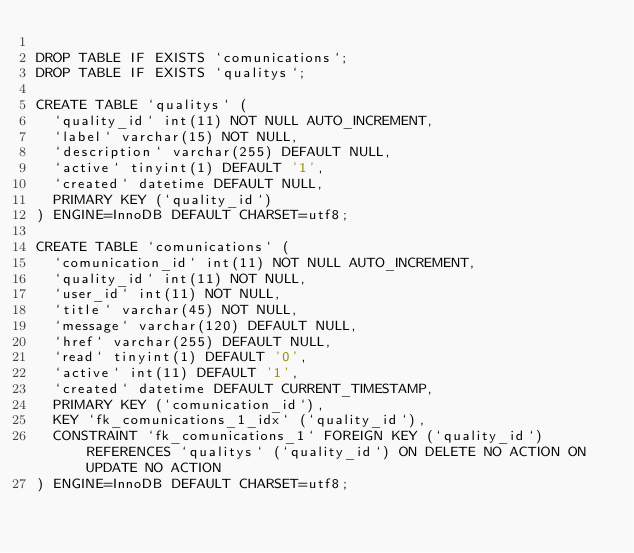<code> <loc_0><loc_0><loc_500><loc_500><_SQL_>
DROP TABLE IF EXISTS `comunications`;
DROP TABLE IF EXISTS `qualitys`;

CREATE TABLE `qualitys` (
  `quality_id` int(11) NOT NULL AUTO_INCREMENT,
  `label` varchar(15) NOT NULL,
  `description` varchar(255) DEFAULT NULL,
  `active` tinyint(1) DEFAULT '1',
  `created` datetime DEFAULT NULL,
  PRIMARY KEY (`quality_id`)
) ENGINE=InnoDB DEFAULT CHARSET=utf8;

CREATE TABLE `comunications` (
  `comunication_id` int(11) NOT NULL AUTO_INCREMENT,
  `quality_id` int(11) NOT NULL,
  `user_id` int(11) NOT NULL,
  `title` varchar(45) NOT NULL,
  `message` varchar(120) DEFAULT NULL,
  `href` varchar(255) DEFAULT NULL,
  `read` tinyint(1) DEFAULT '0',
  `active` int(11) DEFAULT '1',
  `created` datetime DEFAULT CURRENT_TIMESTAMP,
  PRIMARY KEY (`comunication_id`),
  KEY `fk_comunications_1_idx` (`quality_id`),
  CONSTRAINT `fk_comunications_1` FOREIGN KEY (`quality_id`) REFERENCES `qualitys` (`quality_id`) ON DELETE NO ACTION ON UPDATE NO ACTION
) ENGINE=InnoDB DEFAULT CHARSET=utf8;
</code> 